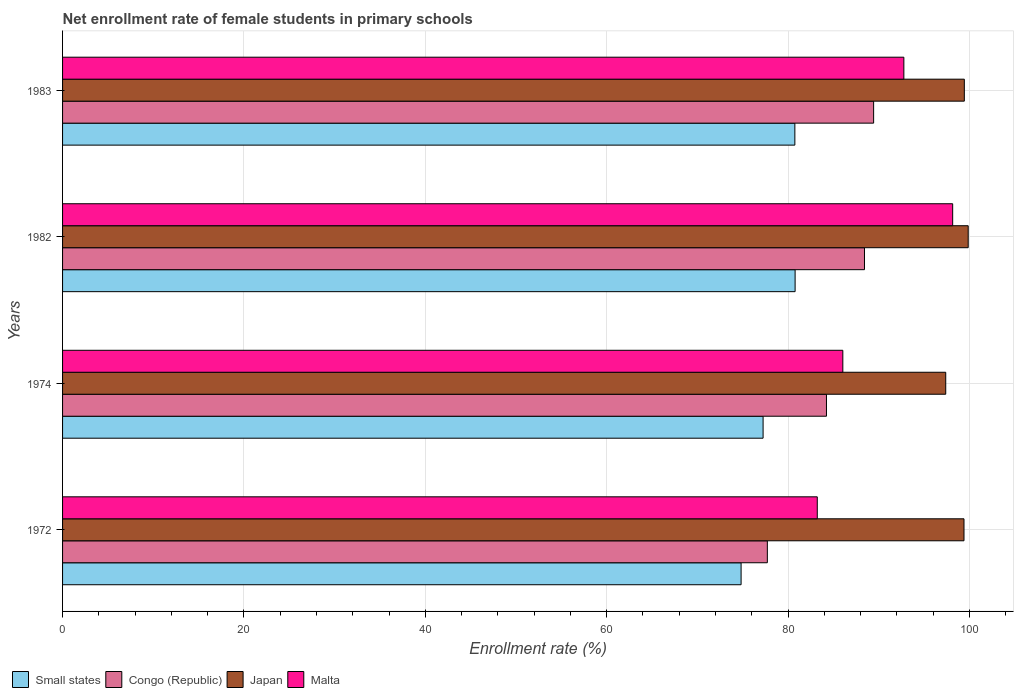How many groups of bars are there?
Keep it short and to the point. 4. What is the label of the 2nd group of bars from the top?
Offer a terse response. 1982. What is the net enrollment rate of female students in primary schools in Malta in 1972?
Keep it short and to the point. 83.22. Across all years, what is the maximum net enrollment rate of female students in primary schools in Small states?
Provide a succinct answer. 80.78. Across all years, what is the minimum net enrollment rate of female students in primary schools in Small states?
Keep it short and to the point. 74.82. In which year was the net enrollment rate of female students in primary schools in Malta maximum?
Provide a short and direct response. 1982. In which year was the net enrollment rate of female students in primary schools in Congo (Republic) minimum?
Keep it short and to the point. 1972. What is the total net enrollment rate of female students in primary schools in Japan in the graph?
Offer a very short reply. 396.1. What is the difference between the net enrollment rate of female students in primary schools in Congo (Republic) in 1972 and that in 1983?
Your answer should be compact. -11.72. What is the difference between the net enrollment rate of female students in primary schools in Congo (Republic) in 1983 and the net enrollment rate of female students in primary schools in Small states in 1972?
Ensure brevity in your answer.  14.61. What is the average net enrollment rate of female students in primary schools in Small states per year?
Provide a succinct answer. 78.4. In the year 1982, what is the difference between the net enrollment rate of female students in primary schools in Small states and net enrollment rate of female students in primary schools in Japan?
Give a very brief answer. -19.09. What is the ratio of the net enrollment rate of female students in primary schools in Congo (Republic) in 1972 to that in 1983?
Give a very brief answer. 0.87. Is the difference between the net enrollment rate of female students in primary schools in Small states in 1982 and 1983 greater than the difference between the net enrollment rate of female students in primary schools in Japan in 1982 and 1983?
Make the answer very short. No. What is the difference between the highest and the second highest net enrollment rate of female students in primary schools in Congo (Republic)?
Provide a succinct answer. 1.01. What is the difference between the highest and the lowest net enrollment rate of female students in primary schools in Congo (Republic)?
Your response must be concise. 11.72. Is it the case that in every year, the sum of the net enrollment rate of female students in primary schools in Japan and net enrollment rate of female students in primary schools in Small states is greater than the sum of net enrollment rate of female students in primary schools in Congo (Republic) and net enrollment rate of female students in primary schools in Malta?
Offer a terse response. No. What does the 1st bar from the top in 1983 represents?
Keep it short and to the point. Malta. What does the 4th bar from the bottom in 1983 represents?
Keep it short and to the point. Malta. How many bars are there?
Your response must be concise. 16. How many years are there in the graph?
Your answer should be compact. 4. What is the difference between two consecutive major ticks on the X-axis?
Your answer should be compact. 20. Are the values on the major ticks of X-axis written in scientific E-notation?
Provide a succinct answer. No. Does the graph contain any zero values?
Provide a succinct answer. No. How many legend labels are there?
Provide a succinct answer. 4. How are the legend labels stacked?
Provide a succinct answer. Horizontal. What is the title of the graph?
Give a very brief answer. Net enrollment rate of female students in primary schools. What is the label or title of the X-axis?
Your response must be concise. Enrollment rate (%). What is the Enrollment rate (%) of Small states in 1972?
Your answer should be very brief. 74.82. What is the Enrollment rate (%) in Congo (Republic) in 1972?
Your answer should be compact. 77.72. What is the Enrollment rate (%) in Japan in 1972?
Keep it short and to the point. 99.4. What is the Enrollment rate (%) in Malta in 1972?
Your answer should be compact. 83.22. What is the Enrollment rate (%) of Small states in 1974?
Ensure brevity in your answer.  77.25. What is the Enrollment rate (%) of Congo (Republic) in 1974?
Ensure brevity in your answer.  84.24. What is the Enrollment rate (%) of Japan in 1974?
Keep it short and to the point. 97.39. What is the Enrollment rate (%) in Malta in 1974?
Provide a succinct answer. 86.04. What is the Enrollment rate (%) of Small states in 1982?
Your answer should be compact. 80.78. What is the Enrollment rate (%) in Congo (Republic) in 1982?
Your response must be concise. 88.43. What is the Enrollment rate (%) in Japan in 1982?
Your response must be concise. 99.87. What is the Enrollment rate (%) in Malta in 1982?
Offer a terse response. 98.16. What is the Enrollment rate (%) of Small states in 1983?
Keep it short and to the point. 80.75. What is the Enrollment rate (%) in Congo (Republic) in 1983?
Your answer should be very brief. 89.44. What is the Enrollment rate (%) in Japan in 1983?
Offer a terse response. 99.44. What is the Enrollment rate (%) of Malta in 1983?
Give a very brief answer. 92.77. Across all years, what is the maximum Enrollment rate (%) in Small states?
Your answer should be very brief. 80.78. Across all years, what is the maximum Enrollment rate (%) of Congo (Republic)?
Make the answer very short. 89.44. Across all years, what is the maximum Enrollment rate (%) in Japan?
Make the answer very short. 99.87. Across all years, what is the maximum Enrollment rate (%) of Malta?
Offer a terse response. 98.16. Across all years, what is the minimum Enrollment rate (%) in Small states?
Keep it short and to the point. 74.82. Across all years, what is the minimum Enrollment rate (%) in Congo (Republic)?
Your answer should be very brief. 77.72. Across all years, what is the minimum Enrollment rate (%) in Japan?
Offer a very short reply. 97.39. Across all years, what is the minimum Enrollment rate (%) in Malta?
Keep it short and to the point. 83.22. What is the total Enrollment rate (%) of Small states in the graph?
Make the answer very short. 313.6. What is the total Enrollment rate (%) of Congo (Republic) in the graph?
Your answer should be compact. 339.82. What is the total Enrollment rate (%) of Japan in the graph?
Your answer should be very brief. 396.1. What is the total Enrollment rate (%) of Malta in the graph?
Provide a short and direct response. 360.19. What is the difference between the Enrollment rate (%) of Small states in 1972 and that in 1974?
Provide a succinct answer. -2.43. What is the difference between the Enrollment rate (%) of Congo (Republic) in 1972 and that in 1974?
Your response must be concise. -6.52. What is the difference between the Enrollment rate (%) of Japan in 1972 and that in 1974?
Ensure brevity in your answer.  2.01. What is the difference between the Enrollment rate (%) in Malta in 1972 and that in 1974?
Ensure brevity in your answer.  -2.82. What is the difference between the Enrollment rate (%) in Small states in 1972 and that in 1982?
Offer a very short reply. -5.96. What is the difference between the Enrollment rate (%) of Congo (Republic) in 1972 and that in 1982?
Your answer should be compact. -10.71. What is the difference between the Enrollment rate (%) of Japan in 1972 and that in 1982?
Your answer should be compact. -0.46. What is the difference between the Enrollment rate (%) of Malta in 1972 and that in 1982?
Offer a terse response. -14.93. What is the difference between the Enrollment rate (%) of Small states in 1972 and that in 1983?
Make the answer very short. -5.93. What is the difference between the Enrollment rate (%) in Congo (Republic) in 1972 and that in 1983?
Give a very brief answer. -11.72. What is the difference between the Enrollment rate (%) of Japan in 1972 and that in 1983?
Your response must be concise. -0.04. What is the difference between the Enrollment rate (%) in Malta in 1972 and that in 1983?
Make the answer very short. -9.55. What is the difference between the Enrollment rate (%) of Small states in 1974 and that in 1982?
Your response must be concise. -3.53. What is the difference between the Enrollment rate (%) of Congo (Republic) in 1974 and that in 1982?
Your answer should be compact. -4.19. What is the difference between the Enrollment rate (%) of Japan in 1974 and that in 1982?
Give a very brief answer. -2.48. What is the difference between the Enrollment rate (%) of Malta in 1974 and that in 1982?
Make the answer very short. -12.11. What is the difference between the Enrollment rate (%) of Small states in 1974 and that in 1983?
Provide a short and direct response. -3.5. What is the difference between the Enrollment rate (%) of Congo (Republic) in 1974 and that in 1983?
Make the answer very short. -5.2. What is the difference between the Enrollment rate (%) of Japan in 1974 and that in 1983?
Provide a succinct answer. -2.05. What is the difference between the Enrollment rate (%) of Malta in 1974 and that in 1983?
Make the answer very short. -6.73. What is the difference between the Enrollment rate (%) of Small states in 1982 and that in 1983?
Your response must be concise. 0.03. What is the difference between the Enrollment rate (%) in Congo (Republic) in 1982 and that in 1983?
Provide a succinct answer. -1.01. What is the difference between the Enrollment rate (%) in Japan in 1982 and that in 1983?
Provide a succinct answer. 0.43. What is the difference between the Enrollment rate (%) of Malta in 1982 and that in 1983?
Your answer should be very brief. 5.38. What is the difference between the Enrollment rate (%) in Small states in 1972 and the Enrollment rate (%) in Congo (Republic) in 1974?
Ensure brevity in your answer.  -9.41. What is the difference between the Enrollment rate (%) in Small states in 1972 and the Enrollment rate (%) in Japan in 1974?
Your answer should be very brief. -22.57. What is the difference between the Enrollment rate (%) of Small states in 1972 and the Enrollment rate (%) of Malta in 1974?
Your response must be concise. -11.22. What is the difference between the Enrollment rate (%) of Congo (Republic) in 1972 and the Enrollment rate (%) of Japan in 1974?
Your answer should be very brief. -19.67. What is the difference between the Enrollment rate (%) in Congo (Republic) in 1972 and the Enrollment rate (%) in Malta in 1974?
Offer a very short reply. -8.32. What is the difference between the Enrollment rate (%) of Japan in 1972 and the Enrollment rate (%) of Malta in 1974?
Provide a succinct answer. 13.36. What is the difference between the Enrollment rate (%) of Small states in 1972 and the Enrollment rate (%) of Congo (Republic) in 1982?
Provide a succinct answer. -13.61. What is the difference between the Enrollment rate (%) of Small states in 1972 and the Enrollment rate (%) of Japan in 1982?
Ensure brevity in your answer.  -25.04. What is the difference between the Enrollment rate (%) of Small states in 1972 and the Enrollment rate (%) of Malta in 1982?
Your response must be concise. -23.33. What is the difference between the Enrollment rate (%) of Congo (Republic) in 1972 and the Enrollment rate (%) of Japan in 1982?
Keep it short and to the point. -22.15. What is the difference between the Enrollment rate (%) of Congo (Republic) in 1972 and the Enrollment rate (%) of Malta in 1982?
Provide a succinct answer. -20.44. What is the difference between the Enrollment rate (%) in Japan in 1972 and the Enrollment rate (%) in Malta in 1982?
Keep it short and to the point. 1.25. What is the difference between the Enrollment rate (%) in Small states in 1972 and the Enrollment rate (%) in Congo (Republic) in 1983?
Keep it short and to the point. -14.61. What is the difference between the Enrollment rate (%) in Small states in 1972 and the Enrollment rate (%) in Japan in 1983?
Your answer should be compact. -24.62. What is the difference between the Enrollment rate (%) of Small states in 1972 and the Enrollment rate (%) of Malta in 1983?
Ensure brevity in your answer.  -17.95. What is the difference between the Enrollment rate (%) of Congo (Republic) in 1972 and the Enrollment rate (%) of Japan in 1983?
Your answer should be compact. -21.72. What is the difference between the Enrollment rate (%) of Congo (Republic) in 1972 and the Enrollment rate (%) of Malta in 1983?
Give a very brief answer. -15.05. What is the difference between the Enrollment rate (%) of Japan in 1972 and the Enrollment rate (%) of Malta in 1983?
Ensure brevity in your answer.  6.63. What is the difference between the Enrollment rate (%) in Small states in 1974 and the Enrollment rate (%) in Congo (Republic) in 1982?
Your answer should be compact. -11.18. What is the difference between the Enrollment rate (%) in Small states in 1974 and the Enrollment rate (%) in Japan in 1982?
Keep it short and to the point. -22.62. What is the difference between the Enrollment rate (%) in Small states in 1974 and the Enrollment rate (%) in Malta in 1982?
Your answer should be compact. -20.91. What is the difference between the Enrollment rate (%) in Congo (Republic) in 1974 and the Enrollment rate (%) in Japan in 1982?
Your answer should be compact. -15.63. What is the difference between the Enrollment rate (%) in Congo (Republic) in 1974 and the Enrollment rate (%) in Malta in 1982?
Ensure brevity in your answer.  -13.92. What is the difference between the Enrollment rate (%) of Japan in 1974 and the Enrollment rate (%) of Malta in 1982?
Your response must be concise. -0.77. What is the difference between the Enrollment rate (%) of Small states in 1974 and the Enrollment rate (%) of Congo (Republic) in 1983?
Provide a succinct answer. -12.19. What is the difference between the Enrollment rate (%) of Small states in 1974 and the Enrollment rate (%) of Japan in 1983?
Your answer should be compact. -22.19. What is the difference between the Enrollment rate (%) in Small states in 1974 and the Enrollment rate (%) in Malta in 1983?
Give a very brief answer. -15.52. What is the difference between the Enrollment rate (%) of Congo (Republic) in 1974 and the Enrollment rate (%) of Japan in 1983?
Provide a succinct answer. -15.2. What is the difference between the Enrollment rate (%) of Congo (Republic) in 1974 and the Enrollment rate (%) of Malta in 1983?
Your answer should be very brief. -8.53. What is the difference between the Enrollment rate (%) of Japan in 1974 and the Enrollment rate (%) of Malta in 1983?
Offer a very short reply. 4.62. What is the difference between the Enrollment rate (%) in Small states in 1982 and the Enrollment rate (%) in Congo (Republic) in 1983?
Offer a terse response. -8.66. What is the difference between the Enrollment rate (%) of Small states in 1982 and the Enrollment rate (%) of Japan in 1983?
Provide a succinct answer. -18.66. What is the difference between the Enrollment rate (%) in Small states in 1982 and the Enrollment rate (%) in Malta in 1983?
Make the answer very short. -11.99. What is the difference between the Enrollment rate (%) of Congo (Republic) in 1982 and the Enrollment rate (%) of Japan in 1983?
Offer a terse response. -11.01. What is the difference between the Enrollment rate (%) of Congo (Republic) in 1982 and the Enrollment rate (%) of Malta in 1983?
Your answer should be very brief. -4.34. What is the difference between the Enrollment rate (%) in Japan in 1982 and the Enrollment rate (%) in Malta in 1983?
Keep it short and to the point. 7.1. What is the average Enrollment rate (%) in Small states per year?
Make the answer very short. 78.4. What is the average Enrollment rate (%) of Congo (Republic) per year?
Make the answer very short. 84.96. What is the average Enrollment rate (%) of Japan per year?
Provide a succinct answer. 99.03. What is the average Enrollment rate (%) in Malta per year?
Offer a very short reply. 90.05. In the year 1972, what is the difference between the Enrollment rate (%) in Small states and Enrollment rate (%) in Congo (Republic)?
Your answer should be compact. -2.9. In the year 1972, what is the difference between the Enrollment rate (%) of Small states and Enrollment rate (%) of Japan?
Offer a very short reply. -24.58. In the year 1972, what is the difference between the Enrollment rate (%) in Small states and Enrollment rate (%) in Malta?
Offer a terse response. -8.4. In the year 1972, what is the difference between the Enrollment rate (%) of Congo (Republic) and Enrollment rate (%) of Japan?
Keep it short and to the point. -21.68. In the year 1972, what is the difference between the Enrollment rate (%) of Congo (Republic) and Enrollment rate (%) of Malta?
Provide a short and direct response. -5.51. In the year 1972, what is the difference between the Enrollment rate (%) in Japan and Enrollment rate (%) in Malta?
Ensure brevity in your answer.  16.18. In the year 1974, what is the difference between the Enrollment rate (%) in Small states and Enrollment rate (%) in Congo (Republic)?
Your answer should be compact. -6.99. In the year 1974, what is the difference between the Enrollment rate (%) in Small states and Enrollment rate (%) in Japan?
Your answer should be compact. -20.14. In the year 1974, what is the difference between the Enrollment rate (%) of Small states and Enrollment rate (%) of Malta?
Provide a succinct answer. -8.79. In the year 1974, what is the difference between the Enrollment rate (%) in Congo (Republic) and Enrollment rate (%) in Japan?
Provide a short and direct response. -13.15. In the year 1974, what is the difference between the Enrollment rate (%) of Congo (Republic) and Enrollment rate (%) of Malta?
Offer a very short reply. -1.8. In the year 1974, what is the difference between the Enrollment rate (%) of Japan and Enrollment rate (%) of Malta?
Provide a succinct answer. 11.35. In the year 1982, what is the difference between the Enrollment rate (%) of Small states and Enrollment rate (%) of Congo (Republic)?
Your response must be concise. -7.65. In the year 1982, what is the difference between the Enrollment rate (%) in Small states and Enrollment rate (%) in Japan?
Offer a terse response. -19.09. In the year 1982, what is the difference between the Enrollment rate (%) in Small states and Enrollment rate (%) in Malta?
Keep it short and to the point. -17.37. In the year 1982, what is the difference between the Enrollment rate (%) of Congo (Republic) and Enrollment rate (%) of Japan?
Offer a terse response. -11.44. In the year 1982, what is the difference between the Enrollment rate (%) of Congo (Republic) and Enrollment rate (%) of Malta?
Your answer should be very brief. -9.73. In the year 1982, what is the difference between the Enrollment rate (%) of Japan and Enrollment rate (%) of Malta?
Your answer should be very brief. 1.71. In the year 1983, what is the difference between the Enrollment rate (%) of Small states and Enrollment rate (%) of Congo (Republic)?
Your answer should be compact. -8.68. In the year 1983, what is the difference between the Enrollment rate (%) of Small states and Enrollment rate (%) of Japan?
Provide a short and direct response. -18.69. In the year 1983, what is the difference between the Enrollment rate (%) of Small states and Enrollment rate (%) of Malta?
Ensure brevity in your answer.  -12.02. In the year 1983, what is the difference between the Enrollment rate (%) of Congo (Republic) and Enrollment rate (%) of Japan?
Your answer should be compact. -10. In the year 1983, what is the difference between the Enrollment rate (%) in Congo (Republic) and Enrollment rate (%) in Malta?
Make the answer very short. -3.33. In the year 1983, what is the difference between the Enrollment rate (%) in Japan and Enrollment rate (%) in Malta?
Provide a succinct answer. 6.67. What is the ratio of the Enrollment rate (%) of Small states in 1972 to that in 1974?
Provide a succinct answer. 0.97. What is the ratio of the Enrollment rate (%) in Congo (Republic) in 1972 to that in 1974?
Give a very brief answer. 0.92. What is the ratio of the Enrollment rate (%) in Japan in 1972 to that in 1974?
Provide a succinct answer. 1.02. What is the ratio of the Enrollment rate (%) in Malta in 1972 to that in 1974?
Your response must be concise. 0.97. What is the ratio of the Enrollment rate (%) of Small states in 1972 to that in 1982?
Offer a very short reply. 0.93. What is the ratio of the Enrollment rate (%) of Congo (Republic) in 1972 to that in 1982?
Your answer should be compact. 0.88. What is the ratio of the Enrollment rate (%) of Japan in 1972 to that in 1982?
Your answer should be compact. 1. What is the ratio of the Enrollment rate (%) of Malta in 1972 to that in 1982?
Make the answer very short. 0.85. What is the ratio of the Enrollment rate (%) of Small states in 1972 to that in 1983?
Your answer should be compact. 0.93. What is the ratio of the Enrollment rate (%) of Congo (Republic) in 1972 to that in 1983?
Ensure brevity in your answer.  0.87. What is the ratio of the Enrollment rate (%) of Malta in 1972 to that in 1983?
Your answer should be very brief. 0.9. What is the ratio of the Enrollment rate (%) of Small states in 1974 to that in 1982?
Your response must be concise. 0.96. What is the ratio of the Enrollment rate (%) of Congo (Republic) in 1974 to that in 1982?
Offer a very short reply. 0.95. What is the ratio of the Enrollment rate (%) of Japan in 1974 to that in 1982?
Make the answer very short. 0.98. What is the ratio of the Enrollment rate (%) of Malta in 1974 to that in 1982?
Ensure brevity in your answer.  0.88. What is the ratio of the Enrollment rate (%) of Small states in 1974 to that in 1983?
Keep it short and to the point. 0.96. What is the ratio of the Enrollment rate (%) of Congo (Republic) in 1974 to that in 1983?
Make the answer very short. 0.94. What is the ratio of the Enrollment rate (%) in Japan in 1974 to that in 1983?
Ensure brevity in your answer.  0.98. What is the ratio of the Enrollment rate (%) in Malta in 1974 to that in 1983?
Provide a short and direct response. 0.93. What is the ratio of the Enrollment rate (%) in Congo (Republic) in 1982 to that in 1983?
Make the answer very short. 0.99. What is the ratio of the Enrollment rate (%) of Japan in 1982 to that in 1983?
Your answer should be compact. 1. What is the ratio of the Enrollment rate (%) of Malta in 1982 to that in 1983?
Offer a very short reply. 1.06. What is the difference between the highest and the second highest Enrollment rate (%) in Small states?
Give a very brief answer. 0.03. What is the difference between the highest and the second highest Enrollment rate (%) of Congo (Republic)?
Make the answer very short. 1.01. What is the difference between the highest and the second highest Enrollment rate (%) of Japan?
Provide a succinct answer. 0.43. What is the difference between the highest and the second highest Enrollment rate (%) of Malta?
Offer a very short reply. 5.38. What is the difference between the highest and the lowest Enrollment rate (%) in Small states?
Your answer should be very brief. 5.96. What is the difference between the highest and the lowest Enrollment rate (%) in Congo (Republic)?
Provide a short and direct response. 11.72. What is the difference between the highest and the lowest Enrollment rate (%) in Japan?
Ensure brevity in your answer.  2.48. What is the difference between the highest and the lowest Enrollment rate (%) of Malta?
Give a very brief answer. 14.93. 